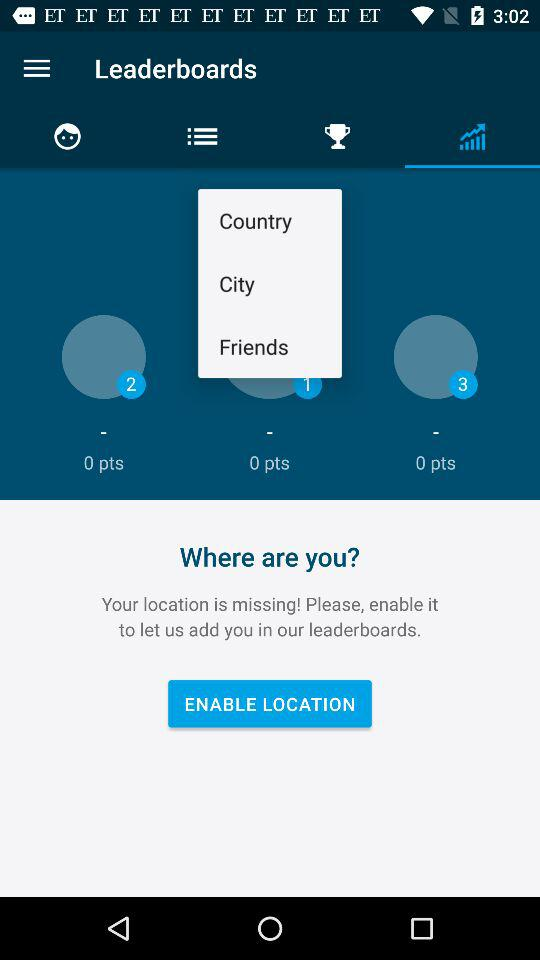How many points are at level 3? The points are 0. 